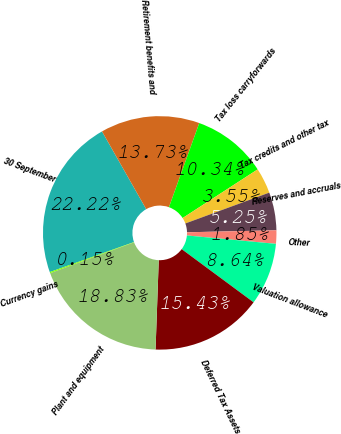Convert chart to OTSL. <chart><loc_0><loc_0><loc_500><loc_500><pie_chart><fcel>30 September<fcel>Retirement benefits and<fcel>Tax loss carryforwards<fcel>Tax credits and other tax<fcel>Reserves and accruals<fcel>Other<fcel>Valuation allowance<fcel>Deferred Tax Assets<fcel>Plant and equipment<fcel>Currency gains<nl><fcel>22.22%<fcel>13.73%<fcel>10.34%<fcel>3.55%<fcel>5.25%<fcel>1.85%<fcel>8.64%<fcel>15.43%<fcel>18.83%<fcel>0.15%<nl></chart> 